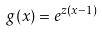Convert formula to latex. <formula><loc_0><loc_0><loc_500><loc_500>g ( x ) = e ^ { z ( x - 1 ) }</formula> 